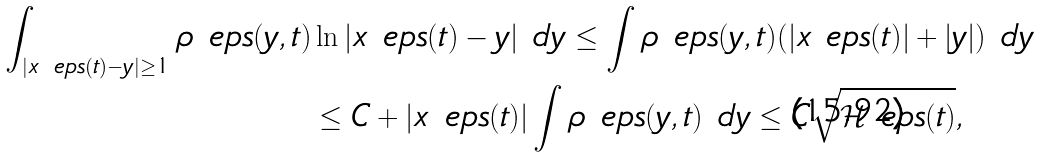<formula> <loc_0><loc_0><loc_500><loc_500>\int _ { | x _ { \ } e p s ( t ) - y | \geq 1 } \rho _ { \ } e p s ( y , t ) & \ln | x _ { \ } e p s ( t ) - y | \ d y \leq \int \rho _ { \ } e p s ( y , t ) ( | x _ { \ } e p s ( t ) | + | y | ) \ d y \\ & \leq C + | x _ { \ } e p s ( t ) | \int \rho _ { \ } e p s ( y , t ) \ d y \leq C \sqrt { \mathcal { H } _ { \ } e p s ( t ) } ,</formula> 